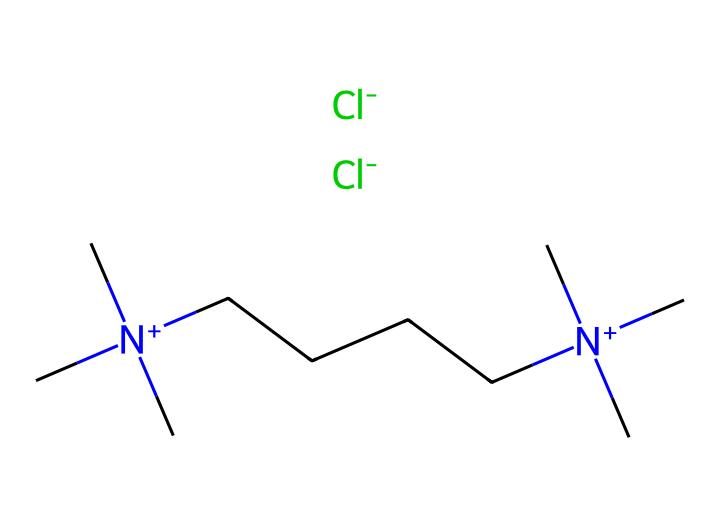What is the total number of nitrogen atoms in this ionic liquid? The structure shows two nitrogen atoms connected to methyl groups, one on each end of the carbon chain. Each nitrogen is indicated by the symbol 'N' in the SMILES representation.
Answer: two How many carbon atoms are present in this ionic liquid? By analyzing the SMILES, we count the number of carbon symbols 'C' and find that there are a total of 14, including those in the methyl and alkyl groups.
Answer: fourteen What type of ions are present in this ionic liquid? The presence of '[Cl-]' indicates that chloride ions are part of the composition, which are characteristic of ionic liquids.
Answer: chloride What is the charge of the nitrogen atoms in this ionic liquid? The notation '[N+]' indicates that both nitrogen atoms carry a positive charge, which is typical for the cationic part of ionic liquids.
Answer: positive Can this ionic liquid be used as a dyeing agent in textiles? The structure suggests a high solubility and miscibility with dyes due to its ionic nature and steric bulk from alkyl chains, making it suitable for dyeing applications.
Answer: yes How does the alkyl chain length affect the solubility of this ionic liquid? Longer alkyl chains typically increase hydrophobic character, potentially improving solubility with non-polar dyes, thus impacting the dyeing efficiency.
Answer: increases What functional groups are indicated in this ionic liquid? The presence of nitrogen and chloride in the structure indicates that the ionic liquid has basic functional groups associated with its ionic characteristics.
Answer: nitrogen and chloride 